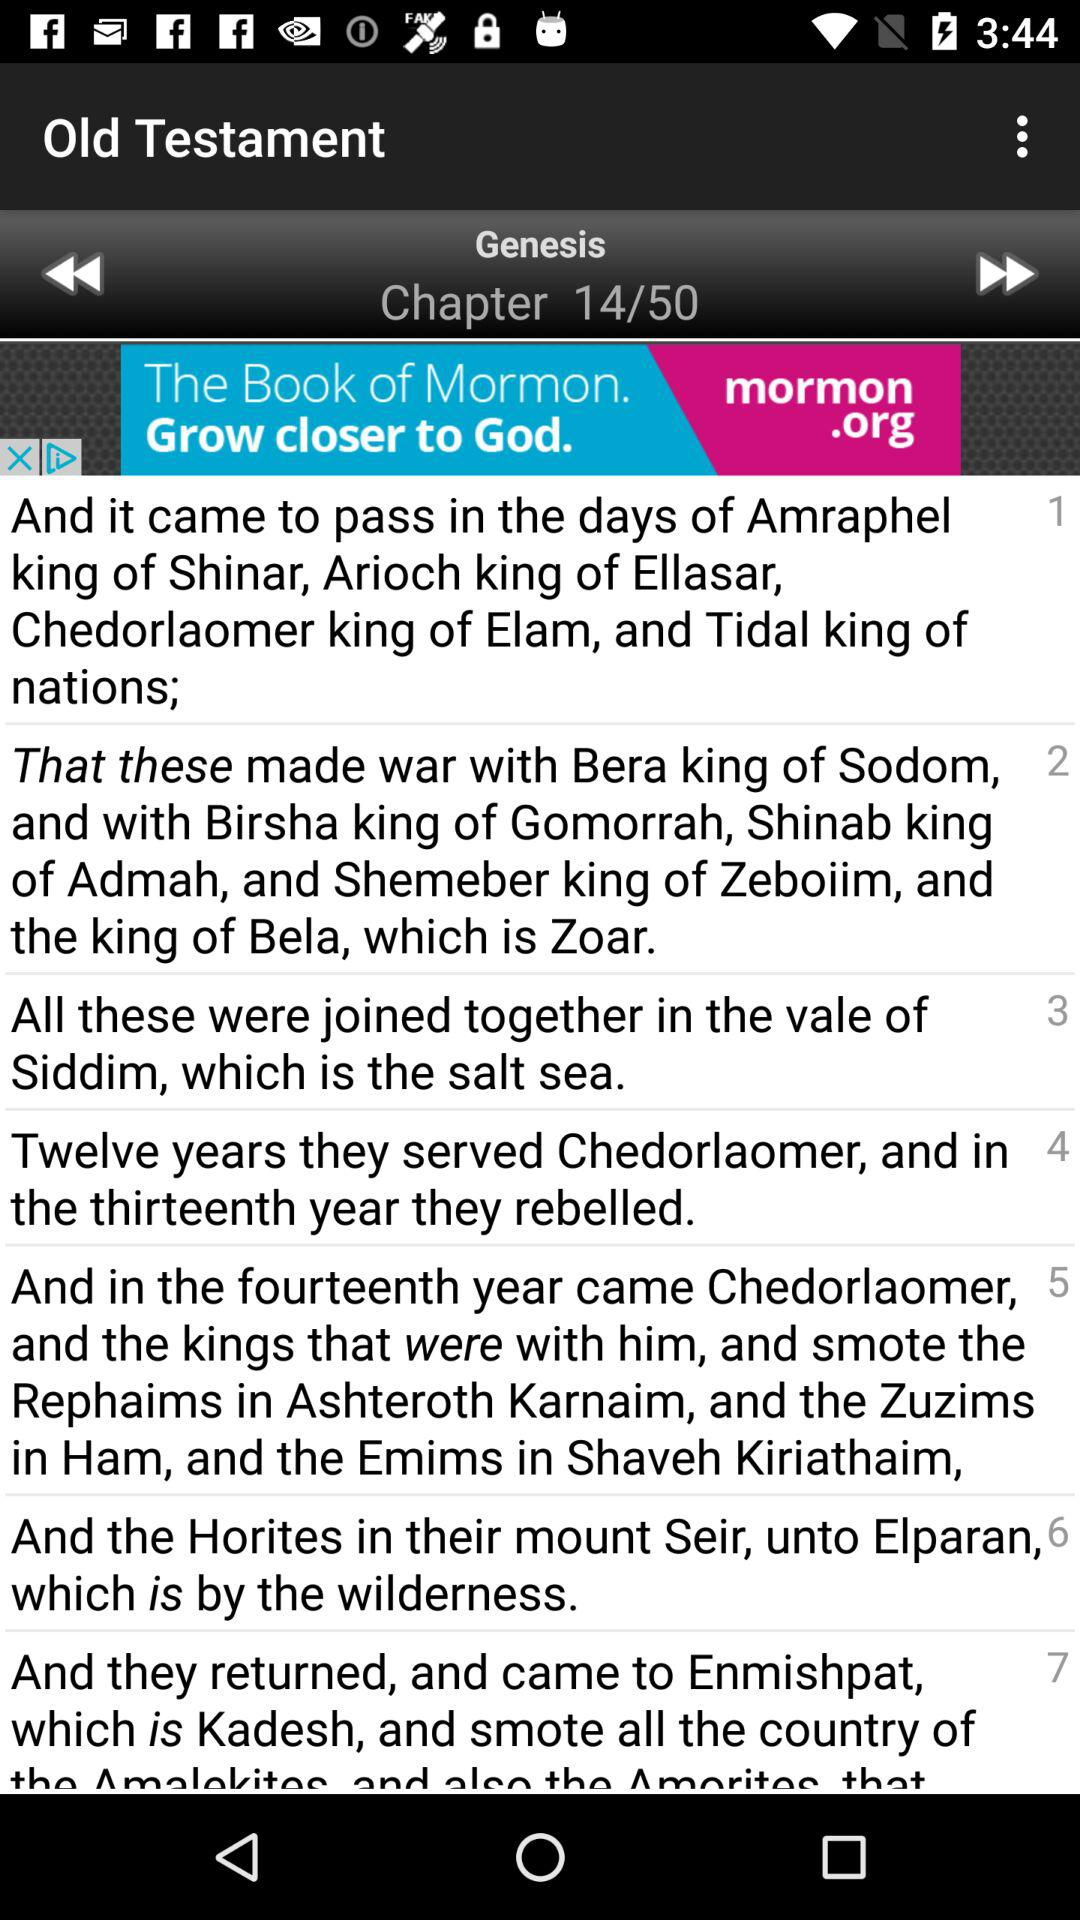What's the current chapter number? The current chapter number is 14. 